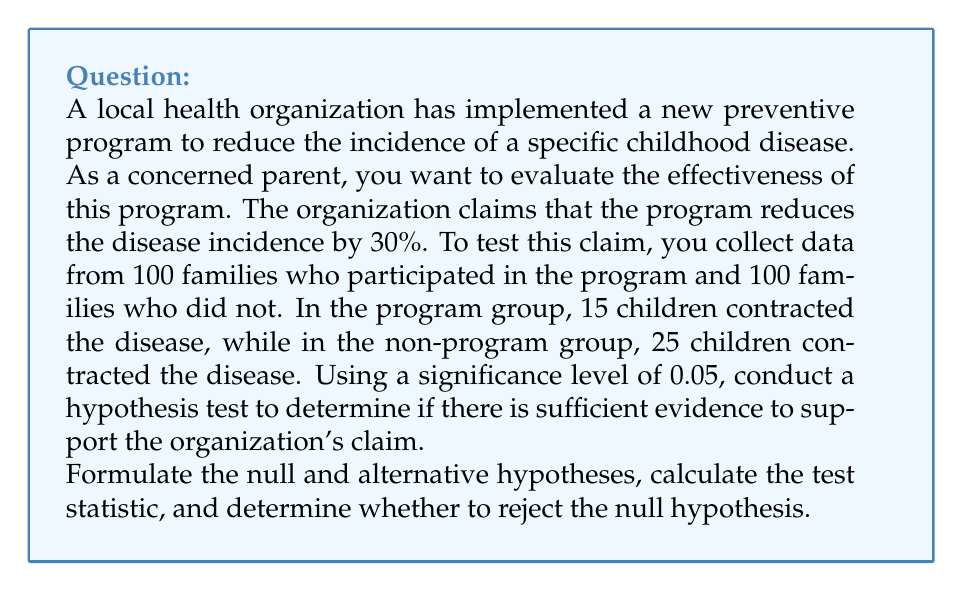Solve this math problem. Let's approach this step-by-step:

1) First, we need to formulate our hypotheses:
   
   Null hypothesis ($H_0$): The program has no effect (p₁ = p₂)
   Alternative hypothesis ($H_a$): The program reduces disease incidence (p₁ < p₂)

   Where p₁ is the proportion of children who contract the disease in the program group, and p₂ is the proportion in the non-program group.

2) Calculate the sample proportions:
   
   $\hat{p}_1 = \frac{15}{100} = 0.15$ (program group)
   $\hat{p}_2 = \frac{25}{100} = 0.25$ (non-program group)

3) Calculate the pooled sample proportion:
   
   $\hat{p} = \frac{15 + 25}{100 + 100} = \frac{40}{200} = 0.20$

4) Calculate the standard error:
   
   $SE = \sqrt{\hat{p}(1-\hat{p})(\frac{1}{n_1} + \frac{1}{n_2})}$
   $SE = \sqrt{0.20(1-0.20)(\frac{1}{100} + \frac{1}{100})} = 0.0566$

5) Calculate the test statistic (z-score):
   
   $z = \frac{(\hat{p}_1 - \hat{p}_2) - 0}{SE} = \frac{0.15 - 0.25}{0.0566} = -1.77$

6) Find the critical value:
   For a one-tailed test at α = 0.05, the critical value is -1.645.

7) Decision rule:
   Reject $H_0$ if z < -1.645

8) Conclusion:
   Since -1.77 < -1.645, we reject the null hypothesis.

There is sufficient evidence to conclude that the program is effective in reducing the incidence of the disease at a 5% significance level.

However, we cannot confirm the claim of a 30% reduction. To do so, we would need to conduct a different test comparing the observed reduction to the claimed 30%.
Answer: Reject the null hypothesis. There is sufficient evidence at the 5% significance level to support the claim that the preventive program reduces the incidence of the disease. 